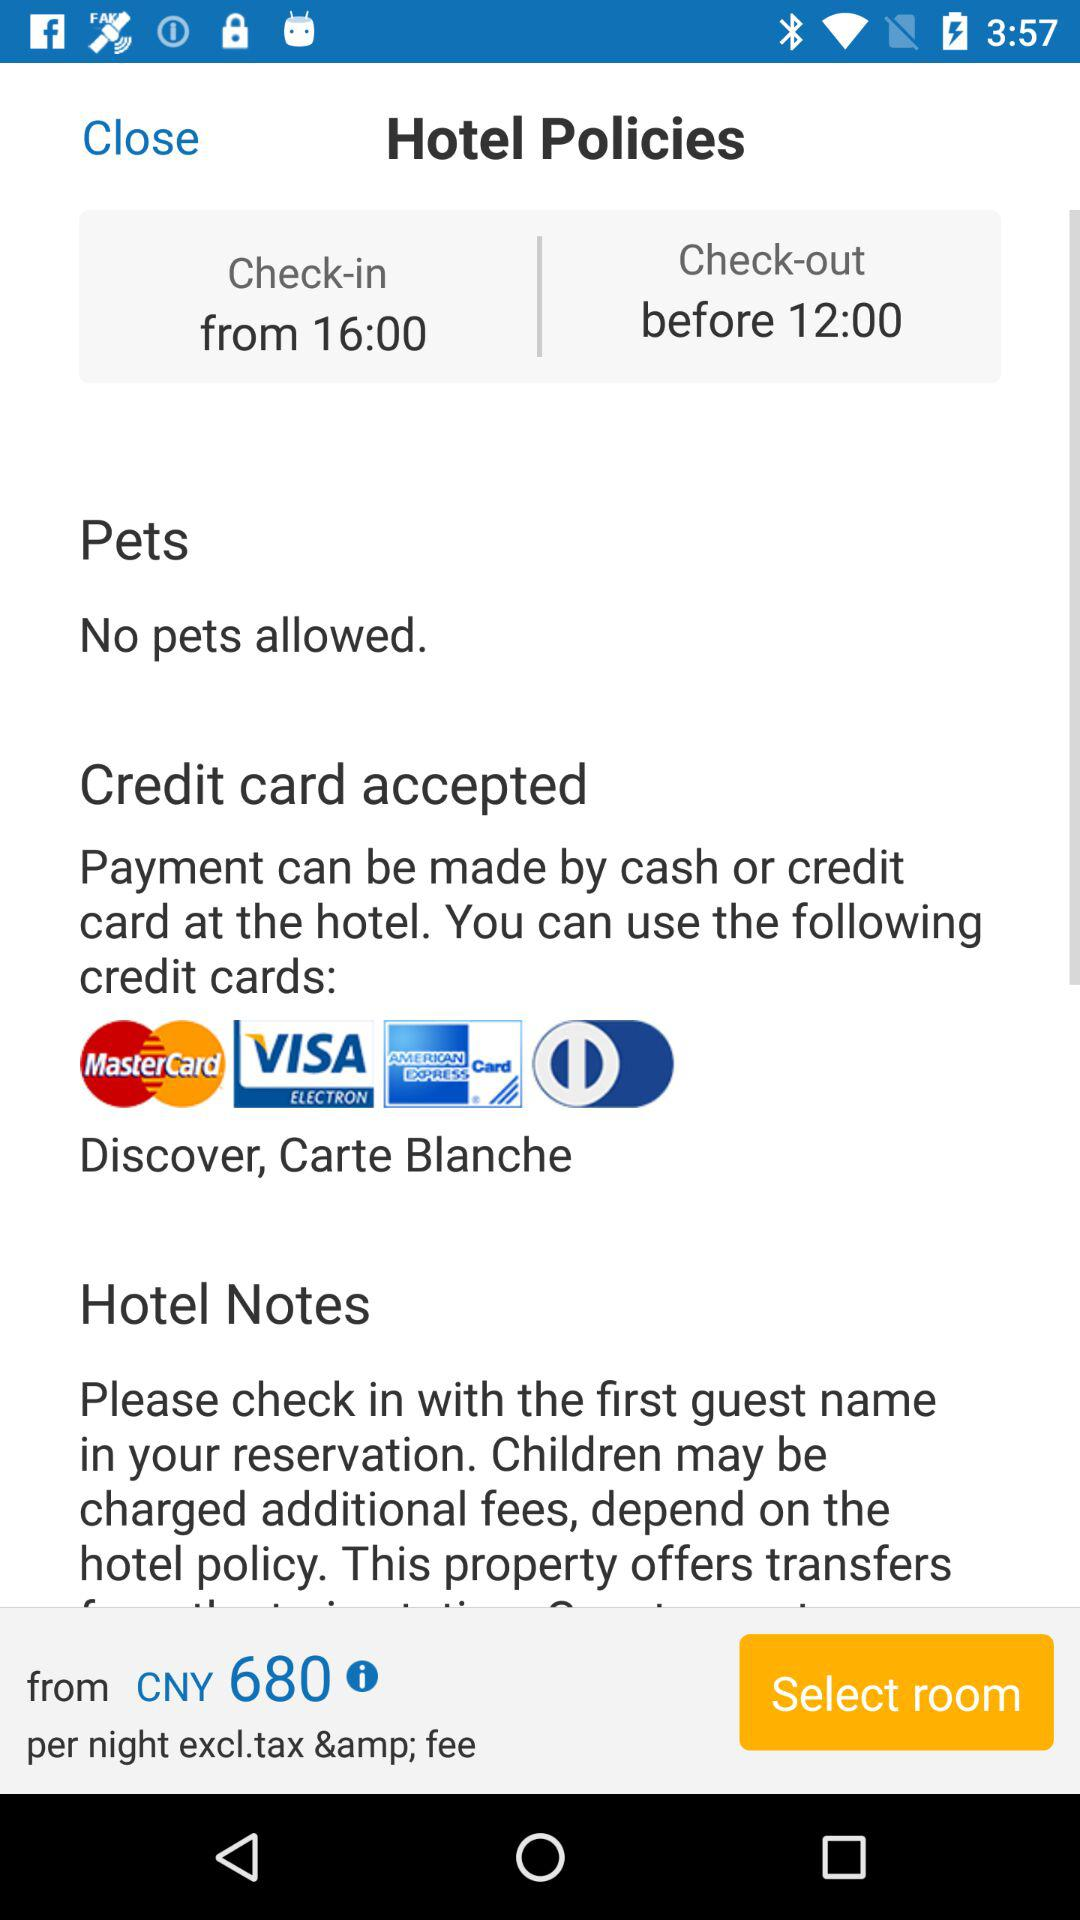What is the cost per night to stay in a hotel? The cost per night to stay in a hotel is 680 CNY. 